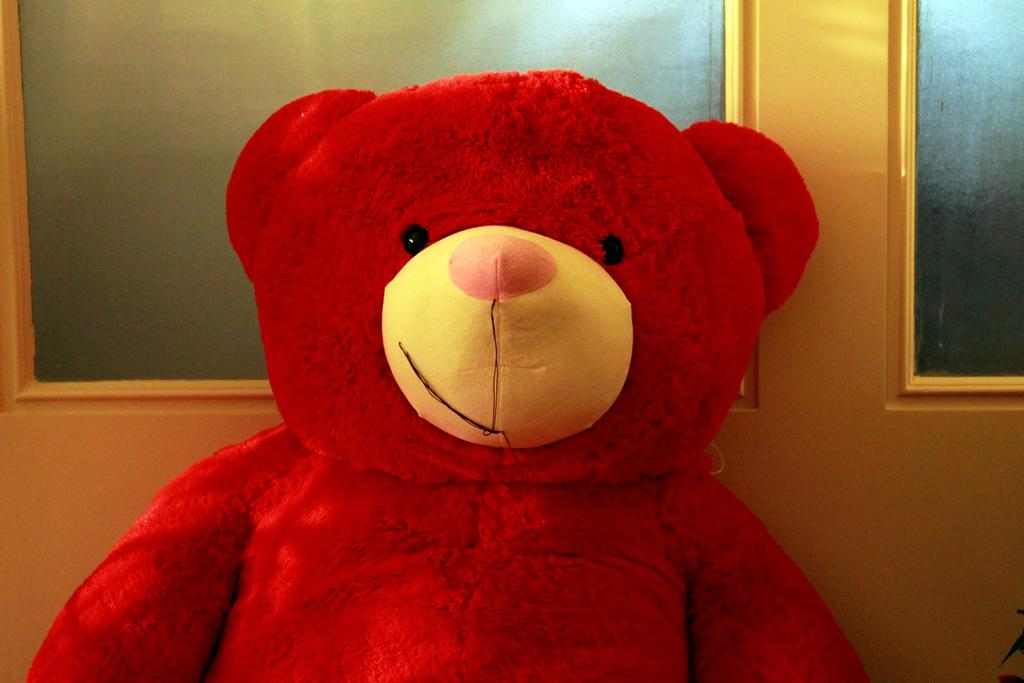What is the main subject in the foreground of the image? There is a red teddy bear in the foreground of the image. What can be seen in the background of the image? There appears to be a window in the background of the image. How many bees are sitting on the teddy bear in the image? There are no bees present in the image; it features a red teddy bear in the foreground and a window in the background. 